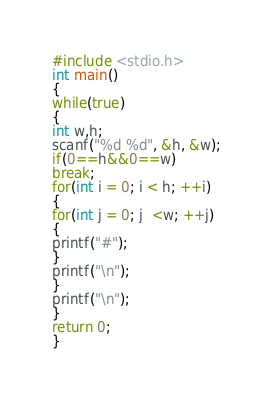Convert code to text. <code><loc_0><loc_0><loc_500><loc_500><_C++_>#include <stdio.h>
int main()
{
while(true)
{
int w,h;
scanf("%d %d", &h, &w);
if(0==h&&0==w)
break;
for(int i = 0; i < h; ++i)
{
for(int j = 0; j  <w; ++j)
{
printf("#");
}
printf("\n");
}
printf("\n");
}
return 0;
}</code> 